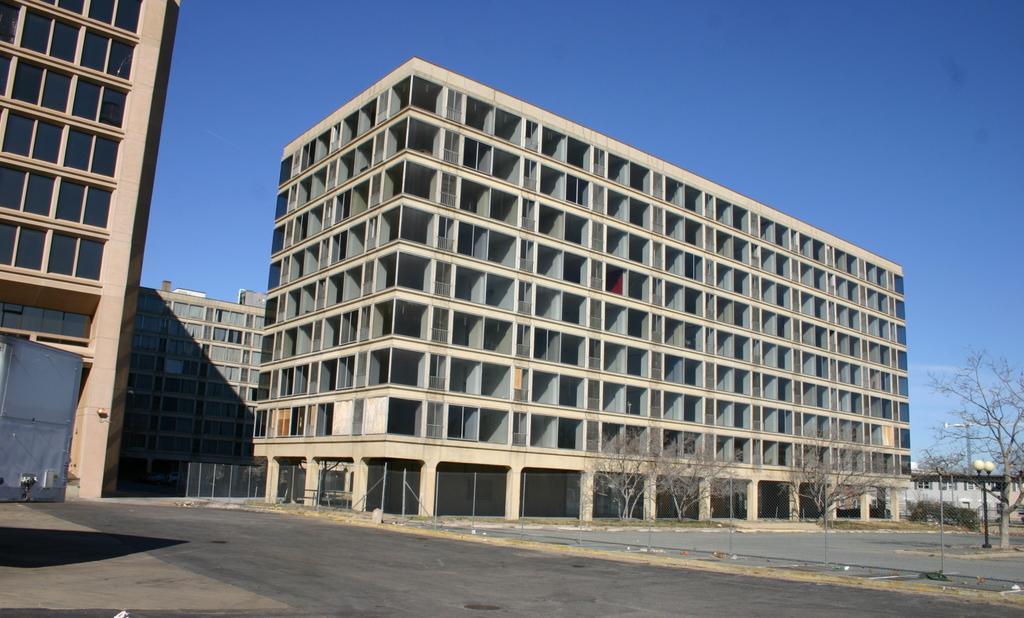Could you give a brief overview of what you see in this image? Here at the bottom we can see road and fence. In the background there are buildings,bare trees,light poles,crane and sky. 